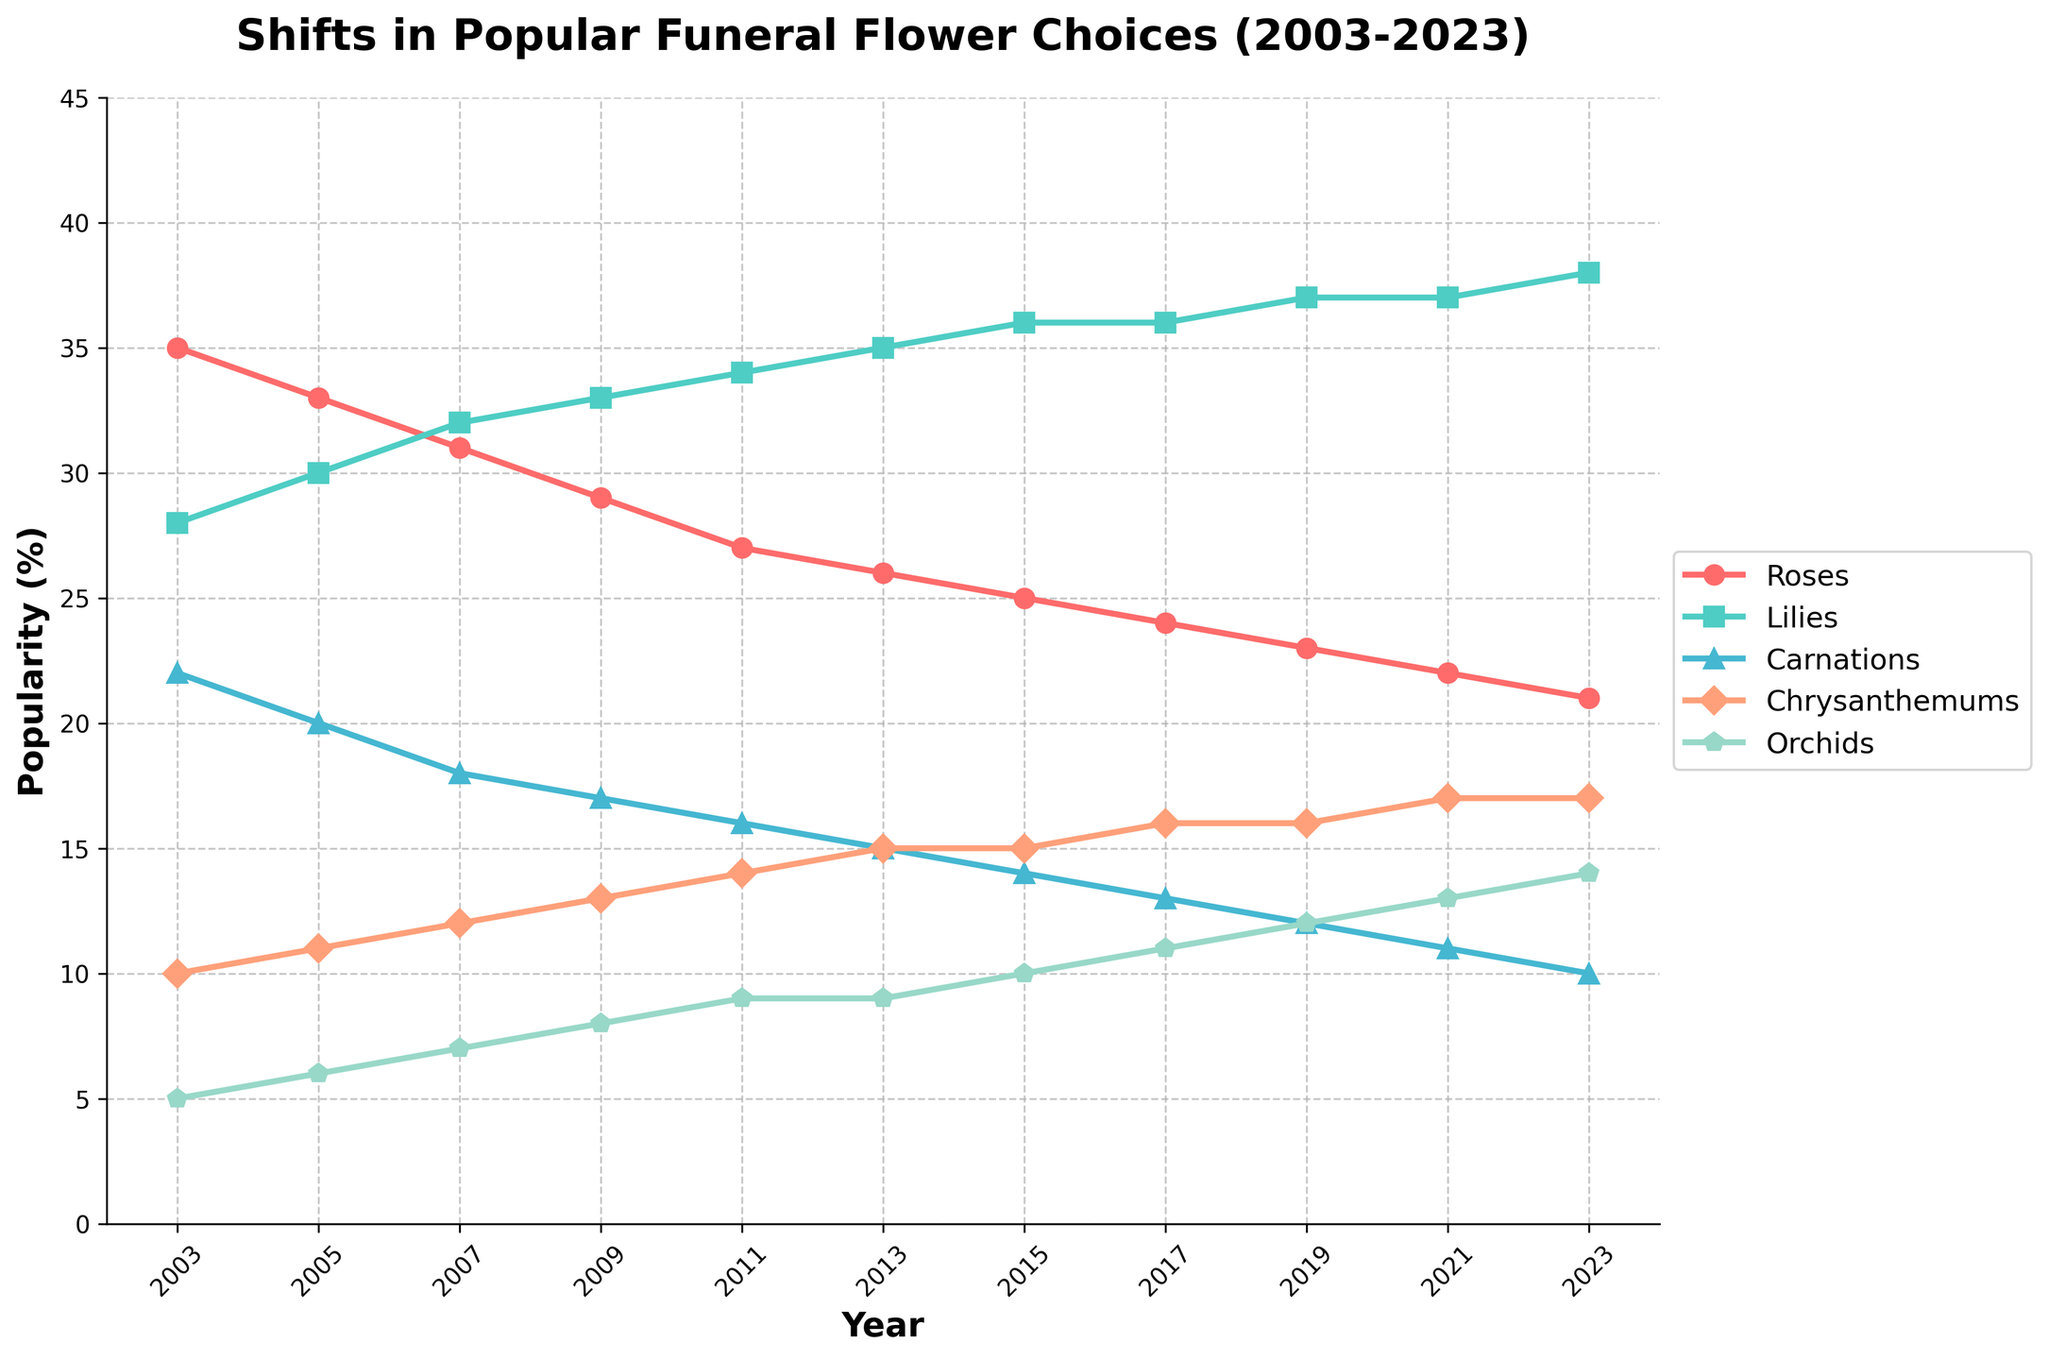What are the top two flowers in popularity over the entire time period shown? By looking at the chart, we can see that Lilies and Roses appear to be the most popular flowers over the entire time period. They consistently have higher percentages compared to other flowers.
Answer: Lilies and Roses How has the popularity of Roses changed from 2003 to 2023? From the figure, we can observe that the percentage of popularity for Roses decreases over time. Starting at 35% in 2003, it declines to 21% in 2023.
Answer: Decreased Which flower showed the greatest increase in popularity from 2003 to 2023? By comparing the starting and ending points for each line, we can see that Orchids increased from 5% to 14%, which is an increase of 9 percentage points, the highest among all flowers.
Answer: Orchids In what year did Lilies first surpass Roses in popularity? From the figure, we can observe that Lilies first became more popular than Roses in 2007.
Answer: 2007 Which flower maintained a steady increase in popularity without any decline? By carefully observing the trends, we see that Lilies consistently increased in popularity from 2003 to 2023 without any periods of decline.
Answer: Lilies What is the combined popularity percentage of Chrysanthemums and Orchids in 2013? From the figure, Chrysanthemums have a popularity of 15% and Orchids have 9% in 2013. Adding these together gives us 15% + 9% = 24%.
Answer: 24% In 2021, how do the popularities of Carnations and Orchids compare? Looking at 2021, Carnations are at 11% while Orchids are at 13%. Hence, Orchids are more popular than Carnations in 2021.
Answer: Orchids are more popular What is the difference in popularity between Lilies and Roses in 2023? In 2023, Lilies have a popularity of 38% and Roses have 21%. The difference is 38% - 21% = 17%.
Answer: 17% Between 2003 and 2023, which flower showed the least amount of overall change in its popularity? By analyzing the trends, we can see that Chrysanthemums experienced smaller fluctuations over the years compared to other flowers, staying relatively stable around the 10-17% range.
Answer: Chrysanthemums What trend can be observed for Carnations from 2003 to 2023? From the figure, the trend shows a steady decline in the popularity of Carnations, starting at 22% in 2003 and decreasing to 10% in 2023.
Answer: Declining 